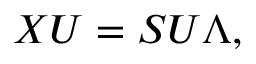Convert formula to latex. <formula><loc_0><loc_0><loc_500><loc_500>X U = S U \Lambda ,</formula> 